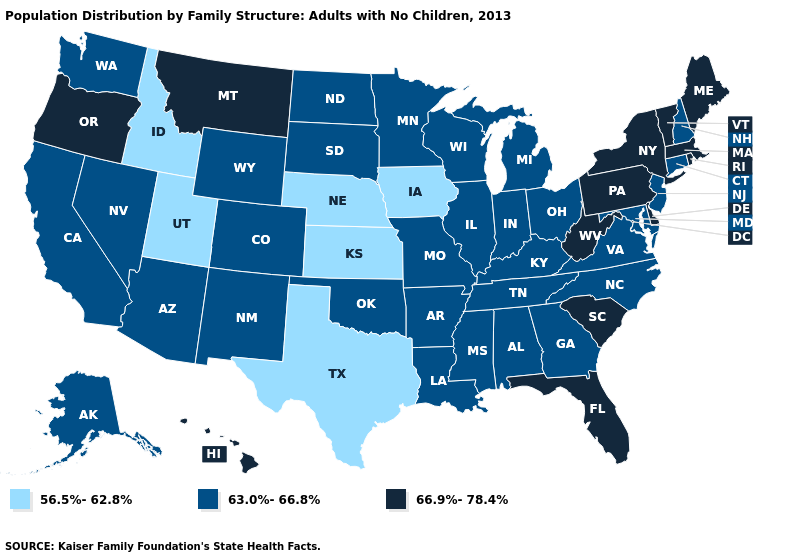Which states have the lowest value in the West?
Give a very brief answer. Idaho, Utah. What is the highest value in the USA?
Short answer required. 66.9%-78.4%. What is the value of Nebraska?
Give a very brief answer. 56.5%-62.8%. Does Oklahoma have a higher value than Iowa?
Write a very short answer. Yes. Name the states that have a value in the range 66.9%-78.4%?
Give a very brief answer. Delaware, Florida, Hawaii, Maine, Massachusetts, Montana, New York, Oregon, Pennsylvania, Rhode Island, South Carolina, Vermont, West Virginia. Among the states that border Louisiana , does Texas have the lowest value?
Give a very brief answer. Yes. Which states have the lowest value in the USA?
Answer briefly. Idaho, Iowa, Kansas, Nebraska, Texas, Utah. What is the value of Illinois?
Concise answer only. 63.0%-66.8%. Name the states that have a value in the range 56.5%-62.8%?
Short answer required. Idaho, Iowa, Kansas, Nebraska, Texas, Utah. What is the value of Alaska?
Concise answer only. 63.0%-66.8%. Name the states that have a value in the range 66.9%-78.4%?
Short answer required. Delaware, Florida, Hawaii, Maine, Massachusetts, Montana, New York, Oregon, Pennsylvania, Rhode Island, South Carolina, Vermont, West Virginia. What is the value of North Carolina?
Quick response, please. 63.0%-66.8%. Name the states that have a value in the range 63.0%-66.8%?
Quick response, please. Alabama, Alaska, Arizona, Arkansas, California, Colorado, Connecticut, Georgia, Illinois, Indiana, Kentucky, Louisiana, Maryland, Michigan, Minnesota, Mississippi, Missouri, Nevada, New Hampshire, New Jersey, New Mexico, North Carolina, North Dakota, Ohio, Oklahoma, South Dakota, Tennessee, Virginia, Washington, Wisconsin, Wyoming. Name the states that have a value in the range 63.0%-66.8%?
Short answer required. Alabama, Alaska, Arizona, Arkansas, California, Colorado, Connecticut, Georgia, Illinois, Indiana, Kentucky, Louisiana, Maryland, Michigan, Minnesota, Mississippi, Missouri, Nevada, New Hampshire, New Jersey, New Mexico, North Carolina, North Dakota, Ohio, Oklahoma, South Dakota, Tennessee, Virginia, Washington, Wisconsin, Wyoming. Name the states that have a value in the range 56.5%-62.8%?
Give a very brief answer. Idaho, Iowa, Kansas, Nebraska, Texas, Utah. 